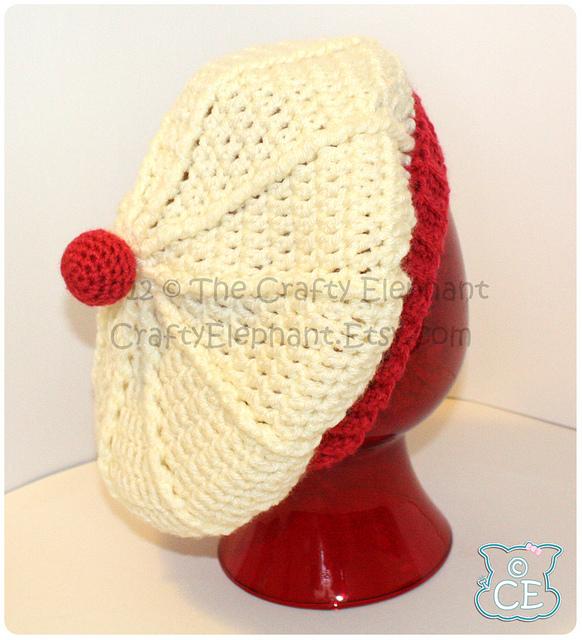What color is the pompom?
Keep it brief. Red. Was the hat hand crocheted?
Be succinct. Yes. What is the hat on?
Give a very brief answer. Mannequin. 